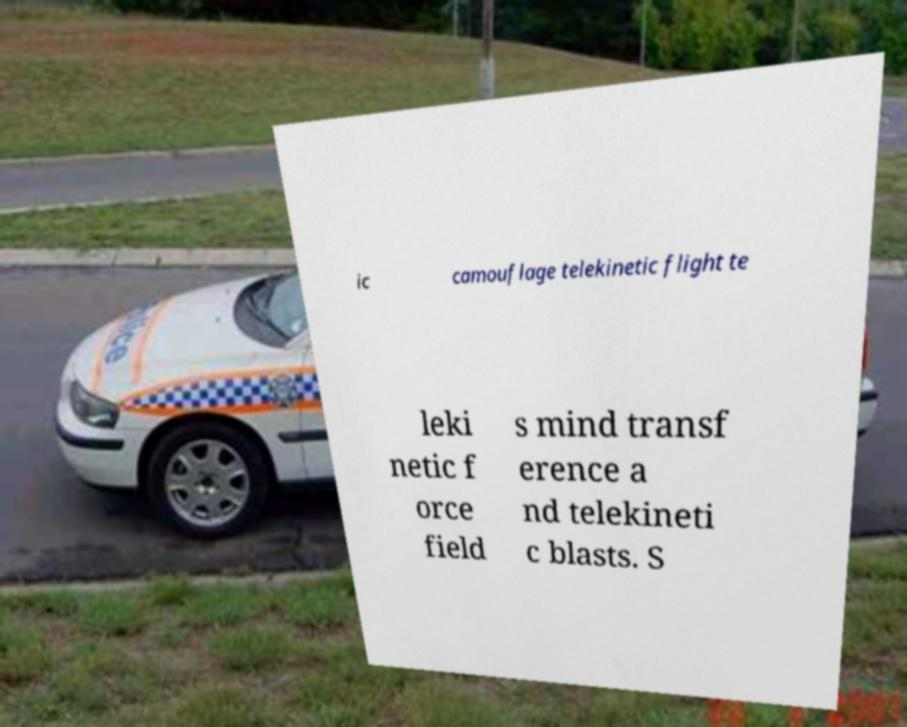There's text embedded in this image that I need extracted. Can you transcribe it verbatim? ic camouflage telekinetic flight te leki netic f orce field s mind transf erence a nd telekineti c blasts. S 